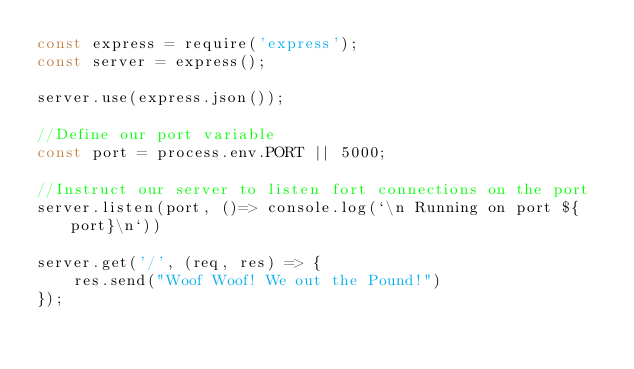<code> <loc_0><loc_0><loc_500><loc_500><_JavaScript_>const express = require('express');
const server = express();

server.use(express.json());

//Define our port variable
const port = process.env.PORT || 5000;

//Instruct our server to listen fort connections on the port
server.listen(port, ()=> console.log(`\n Running on port ${port}\n`))

server.get('/', (req, res) => {
    res.send("Woof Woof! We out the Pound!")
});</code> 